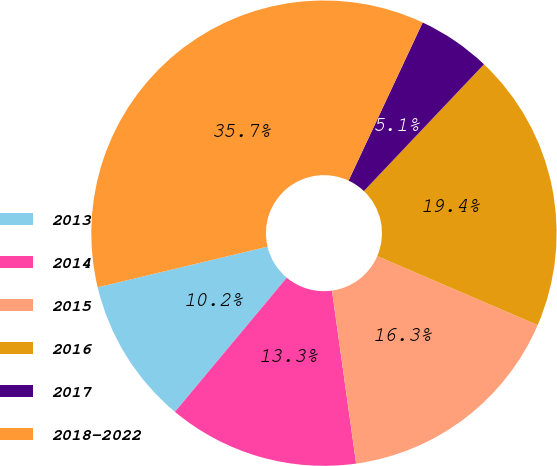Convert chart to OTSL. <chart><loc_0><loc_0><loc_500><loc_500><pie_chart><fcel>2013<fcel>2014<fcel>2015<fcel>2016<fcel>2017<fcel>2018-2022<nl><fcel>10.2%<fcel>13.27%<fcel>16.33%<fcel>19.39%<fcel>5.1%<fcel>35.71%<nl></chart> 